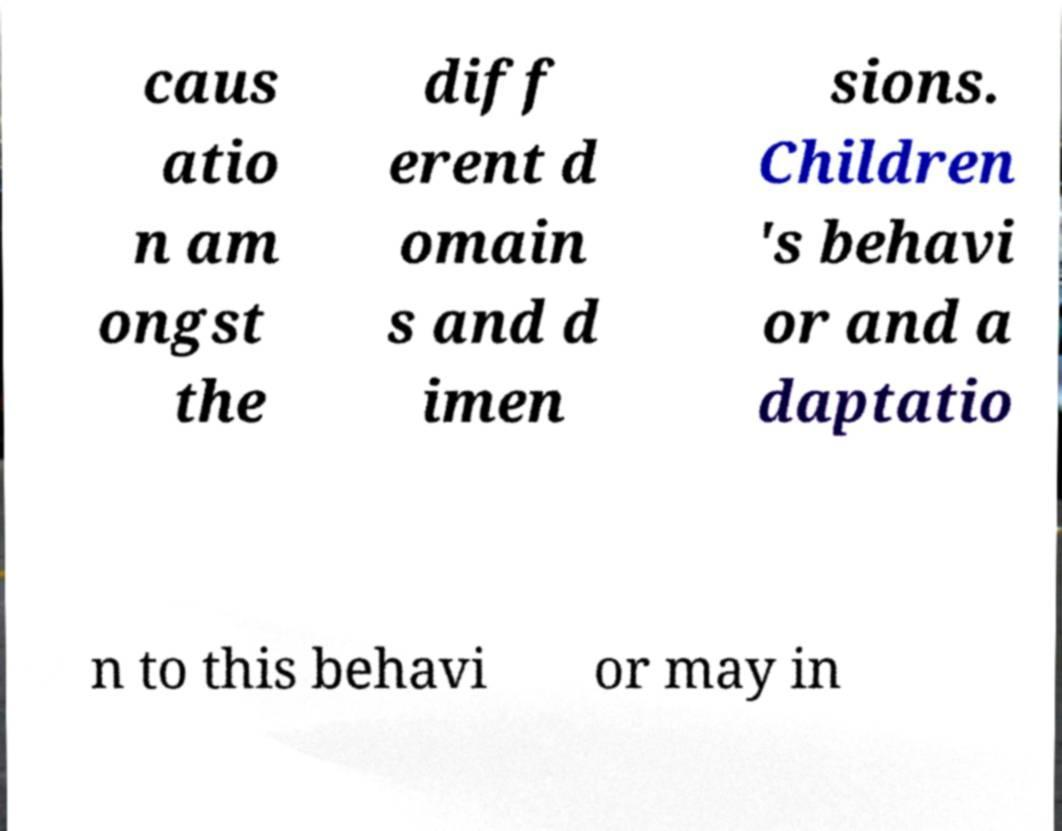For documentation purposes, I need the text within this image transcribed. Could you provide that? caus atio n am ongst the diff erent d omain s and d imen sions. Children 's behavi or and a daptatio n to this behavi or may in 